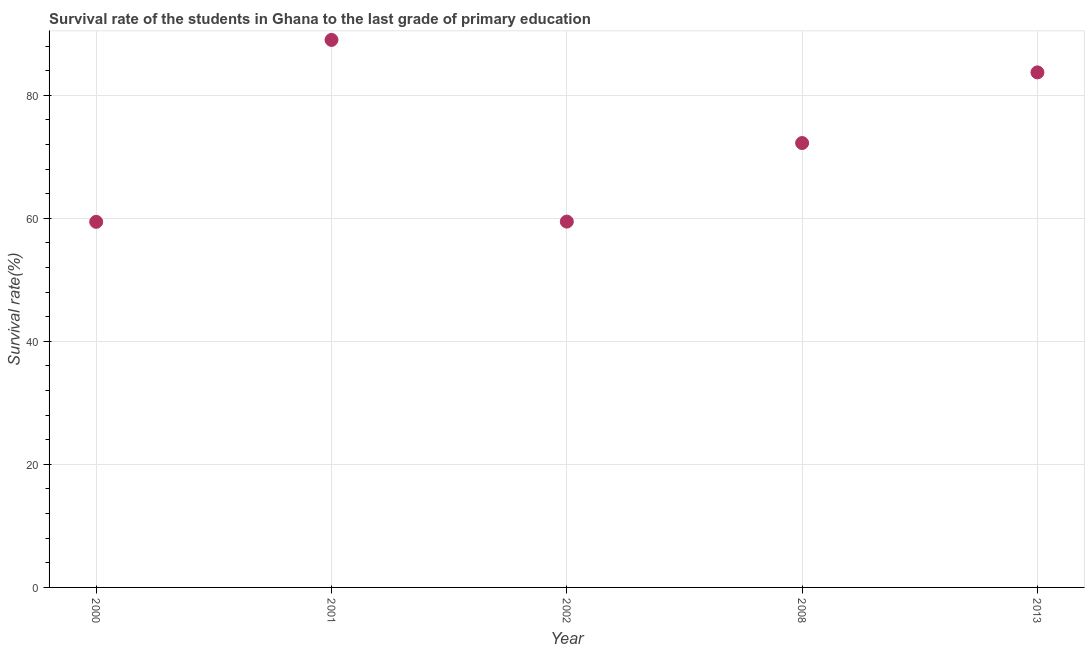What is the survival rate in primary education in 2001?
Offer a very short reply. 88.99. Across all years, what is the maximum survival rate in primary education?
Give a very brief answer. 88.99. Across all years, what is the minimum survival rate in primary education?
Your answer should be compact. 59.42. What is the sum of the survival rate in primary education?
Your answer should be compact. 363.82. What is the difference between the survival rate in primary education in 2000 and 2001?
Make the answer very short. -29.57. What is the average survival rate in primary education per year?
Give a very brief answer. 72.76. What is the median survival rate in primary education?
Offer a very short reply. 72.23. In how many years, is the survival rate in primary education greater than 84 %?
Ensure brevity in your answer.  1. Do a majority of the years between 2001 and 2000 (inclusive) have survival rate in primary education greater than 44 %?
Offer a terse response. No. What is the ratio of the survival rate in primary education in 2000 to that in 2013?
Ensure brevity in your answer.  0.71. Is the difference between the survival rate in primary education in 2001 and 2008 greater than the difference between any two years?
Your answer should be very brief. No. What is the difference between the highest and the second highest survival rate in primary education?
Provide a short and direct response. 5.28. What is the difference between the highest and the lowest survival rate in primary education?
Offer a very short reply. 29.57. Does the survival rate in primary education monotonically increase over the years?
Your answer should be very brief. No. How many dotlines are there?
Keep it short and to the point. 1. How many years are there in the graph?
Your response must be concise. 5. What is the difference between two consecutive major ticks on the Y-axis?
Offer a terse response. 20. Are the values on the major ticks of Y-axis written in scientific E-notation?
Make the answer very short. No. What is the title of the graph?
Your answer should be compact. Survival rate of the students in Ghana to the last grade of primary education. What is the label or title of the X-axis?
Offer a very short reply. Year. What is the label or title of the Y-axis?
Your answer should be very brief. Survival rate(%). What is the Survival rate(%) in 2000?
Your answer should be compact. 59.42. What is the Survival rate(%) in 2001?
Your answer should be very brief. 88.99. What is the Survival rate(%) in 2002?
Your answer should be very brief. 59.46. What is the Survival rate(%) in 2008?
Give a very brief answer. 72.23. What is the Survival rate(%) in 2013?
Keep it short and to the point. 83.71. What is the difference between the Survival rate(%) in 2000 and 2001?
Provide a short and direct response. -29.57. What is the difference between the Survival rate(%) in 2000 and 2002?
Make the answer very short. -0.04. What is the difference between the Survival rate(%) in 2000 and 2008?
Offer a terse response. -12.81. What is the difference between the Survival rate(%) in 2000 and 2013?
Ensure brevity in your answer.  -24.29. What is the difference between the Survival rate(%) in 2001 and 2002?
Keep it short and to the point. 29.53. What is the difference between the Survival rate(%) in 2001 and 2008?
Give a very brief answer. 16.76. What is the difference between the Survival rate(%) in 2001 and 2013?
Offer a terse response. 5.28. What is the difference between the Survival rate(%) in 2002 and 2008?
Make the answer very short. -12.77. What is the difference between the Survival rate(%) in 2002 and 2013?
Ensure brevity in your answer.  -24.25. What is the difference between the Survival rate(%) in 2008 and 2013?
Offer a terse response. -11.48. What is the ratio of the Survival rate(%) in 2000 to that in 2001?
Offer a terse response. 0.67. What is the ratio of the Survival rate(%) in 2000 to that in 2002?
Ensure brevity in your answer.  1. What is the ratio of the Survival rate(%) in 2000 to that in 2008?
Your answer should be very brief. 0.82. What is the ratio of the Survival rate(%) in 2000 to that in 2013?
Give a very brief answer. 0.71. What is the ratio of the Survival rate(%) in 2001 to that in 2002?
Keep it short and to the point. 1.5. What is the ratio of the Survival rate(%) in 2001 to that in 2008?
Your response must be concise. 1.23. What is the ratio of the Survival rate(%) in 2001 to that in 2013?
Your response must be concise. 1.06. What is the ratio of the Survival rate(%) in 2002 to that in 2008?
Make the answer very short. 0.82. What is the ratio of the Survival rate(%) in 2002 to that in 2013?
Make the answer very short. 0.71. What is the ratio of the Survival rate(%) in 2008 to that in 2013?
Ensure brevity in your answer.  0.86. 